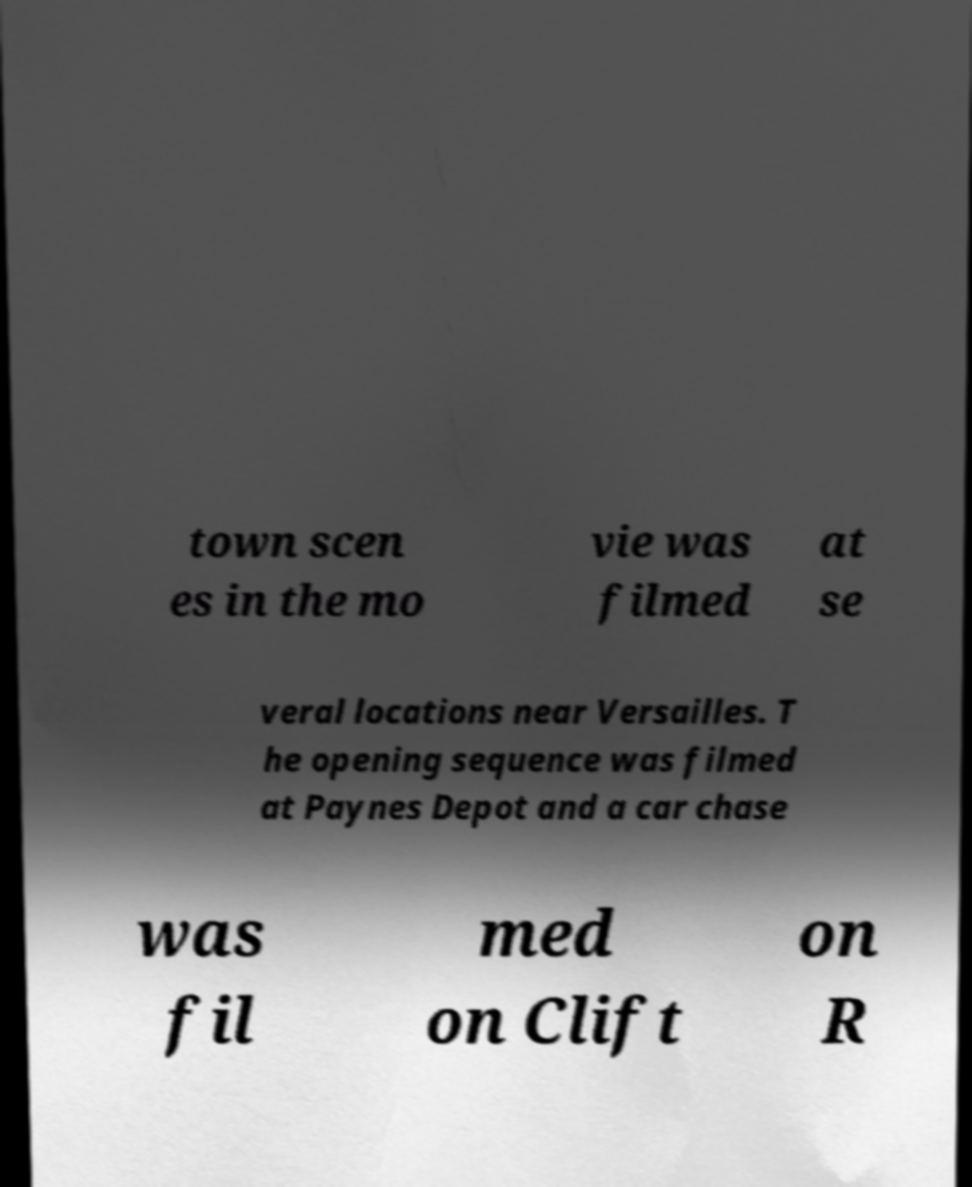What messages or text are displayed in this image? I need them in a readable, typed format. town scen es in the mo vie was filmed at se veral locations near Versailles. T he opening sequence was filmed at Paynes Depot and a car chase was fil med on Clift on R 